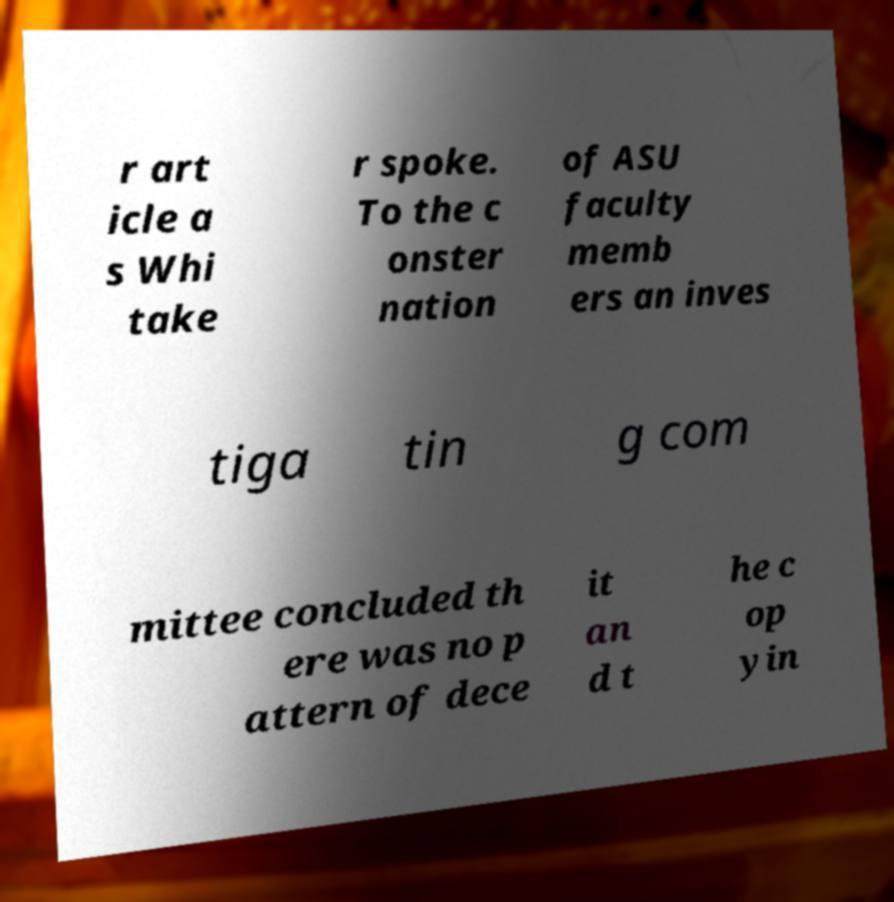Could you assist in decoding the text presented in this image and type it out clearly? r art icle a s Whi take r spoke. To the c onster nation of ASU faculty memb ers an inves tiga tin g com mittee concluded th ere was no p attern of dece it an d t he c op yin 